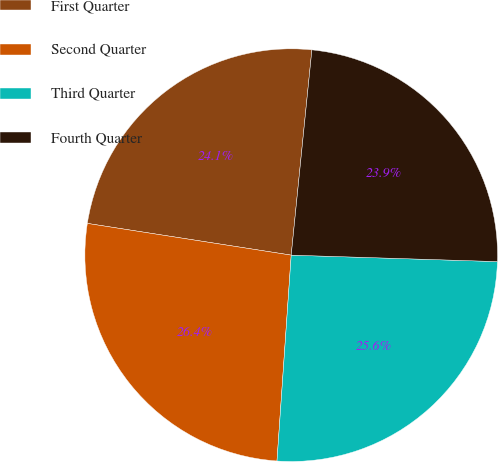Convert chart. <chart><loc_0><loc_0><loc_500><loc_500><pie_chart><fcel>First Quarter<fcel>Second Quarter<fcel>Third Quarter<fcel>Fourth Quarter<nl><fcel>24.14%<fcel>26.36%<fcel>25.6%<fcel>23.9%<nl></chart> 